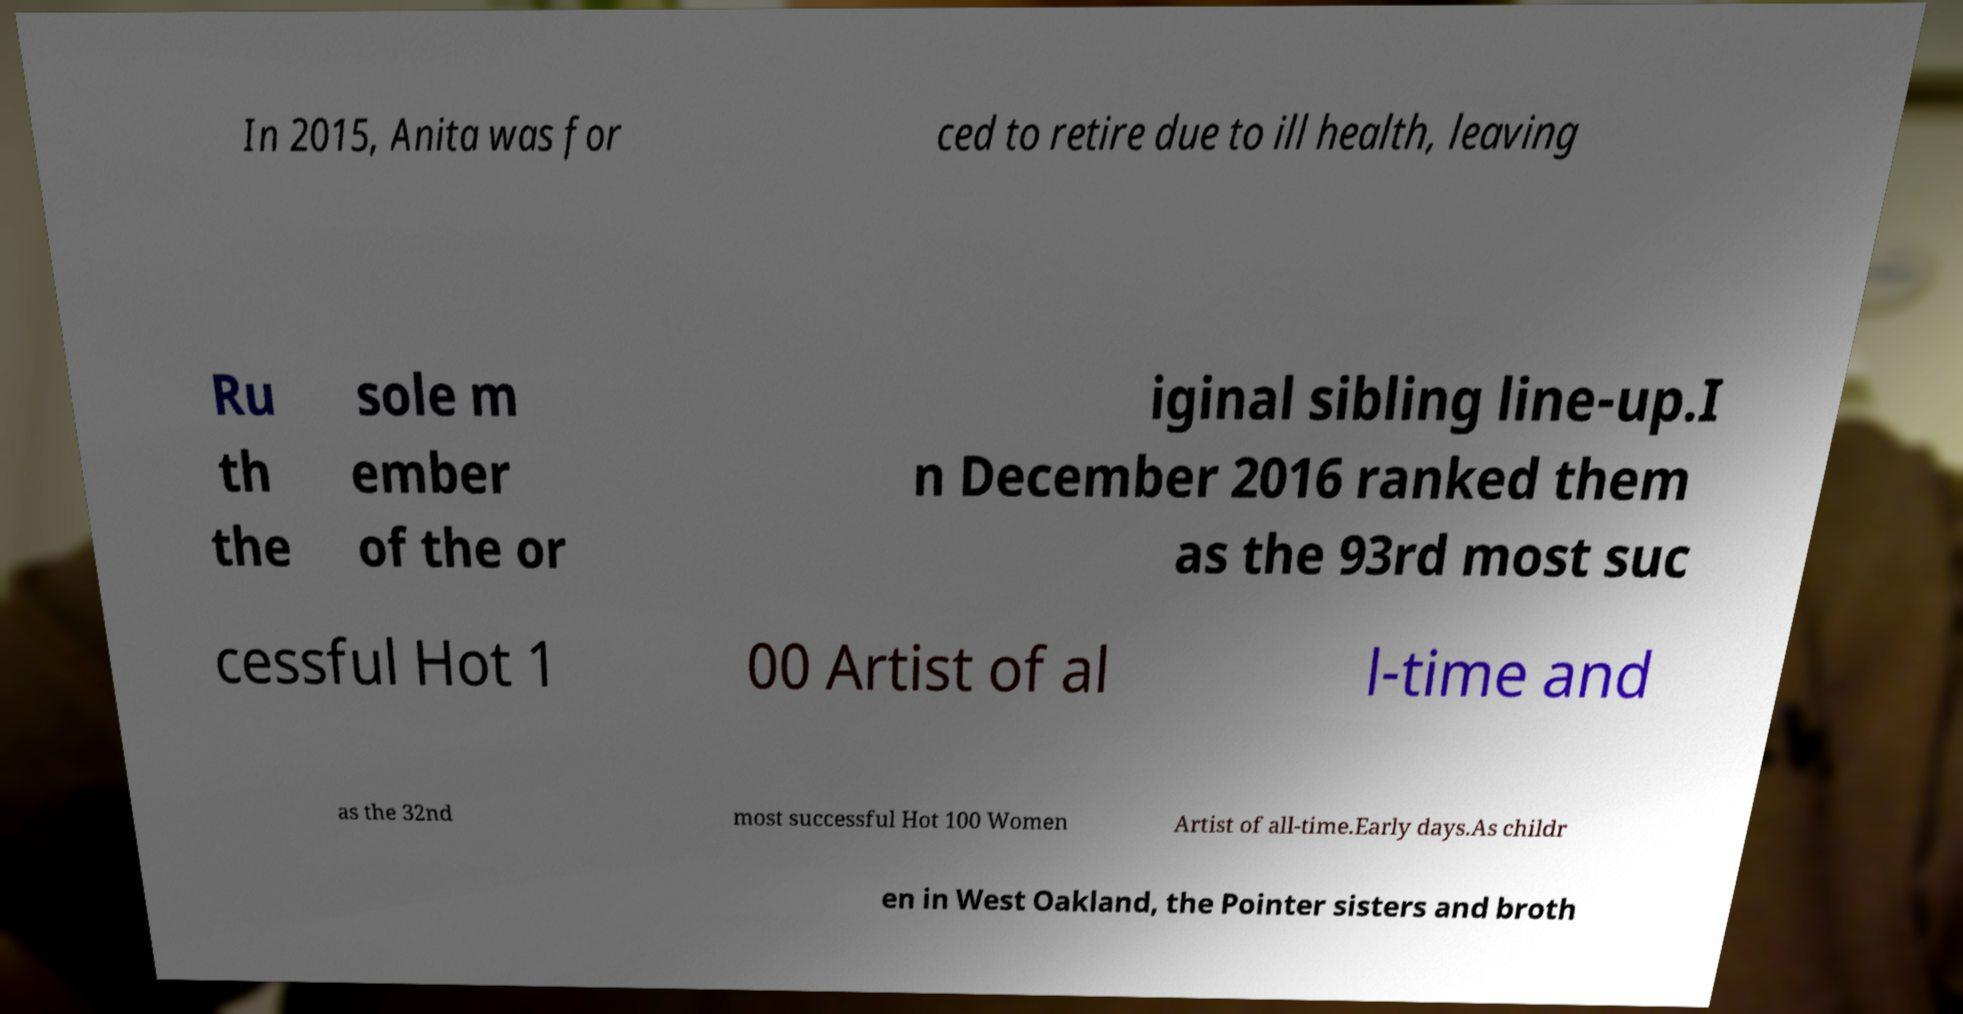I need the written content from this picture converted into text. Can you do that? In 2015, Anita was for ced to retire due to ill health, leaving Ru th the sole m ember of the or iginal sibling line-up.I n December 2016 ranked them as the 93rd most suc cessful Hot 1 00 Artist of al l-time and as the 32nd most successful Hot 100 Women Artist of all-time.Early days.As childr en in West Oakland, the Pointer sisters and broth 